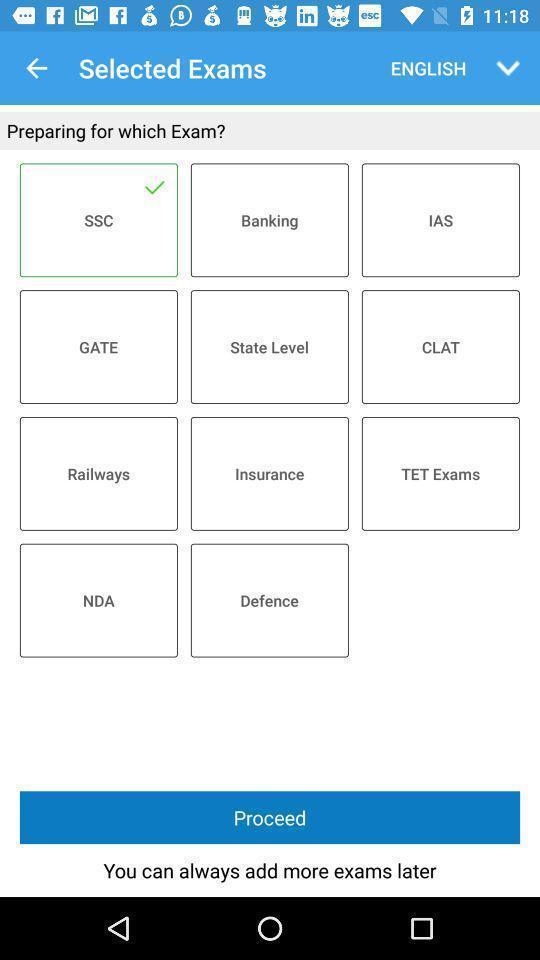Summarize the information in this screenshot. Page to select exams. 